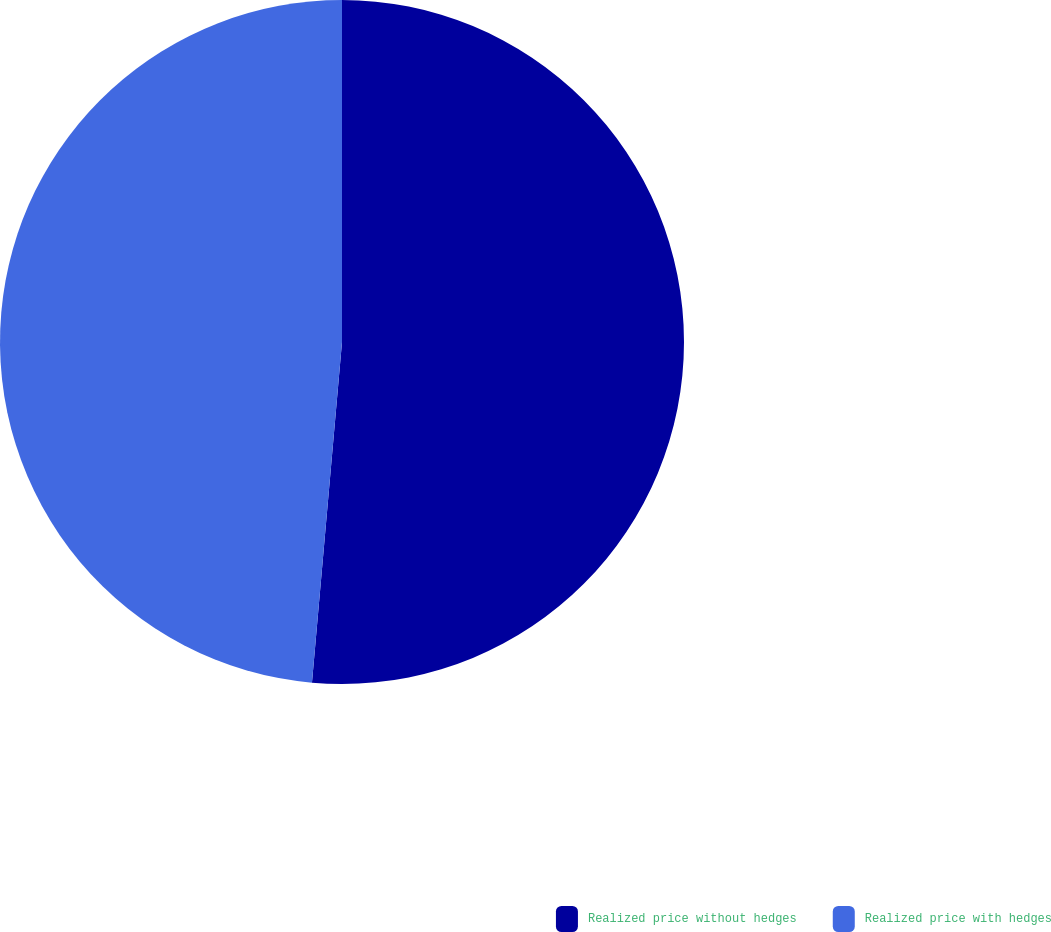Convert chart to OTSL. <chart><loc_0><loc_0><loc_500><loc_500><pie_chart><fcel>Realized price without hedges<fcel>Realized price with hedges<nl><fcel>51.4%<fcel>48.6%<nl></chart> 